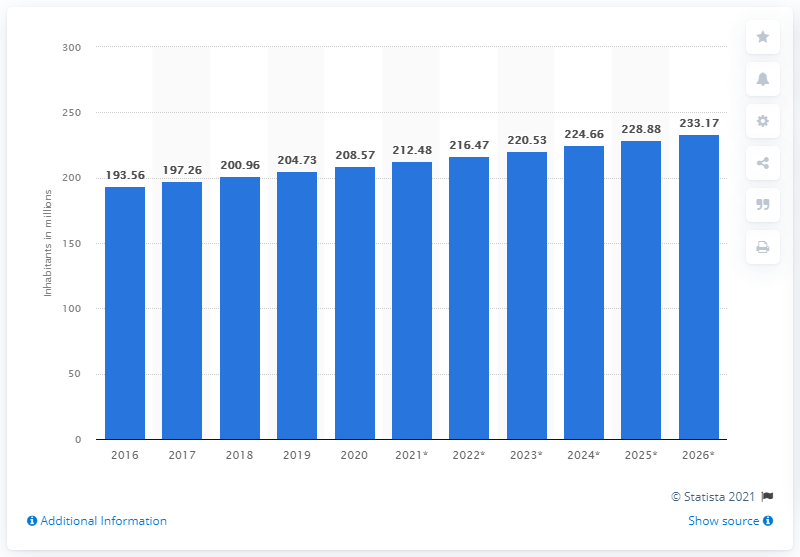Mention a couple of crucial points in this snapshot. The population of Pakistan in 2020 was approximately 208.57 million. 